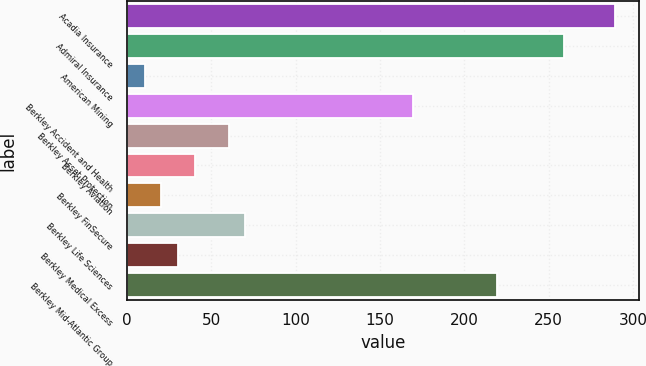Convert chart to OTSL. <chart><loc_0><loc_0><loc_500><loc_500><bar_chart><fcel>Acadia Insurance<fcel>Admiral Insurance<fcel>American Mining<fcel>Berkley Accident and Health<fcel>Berkley Asset Protection<fcel>Berkley Aviation<fcel>Berkley FinSecure<fcel>Berkley Life Sciences<fcel>Berkley Medical Excess<fcel>Berkley Mid-Atlantic Group<nl><fcel>289.24<fcel>259.36<fcel>10.36<fcel>169.72<fcel>60.16<fcel>40.24<fcel>20.32<fcel>70.12<fcel>30.28<fcel>219.52<nl></chart> 